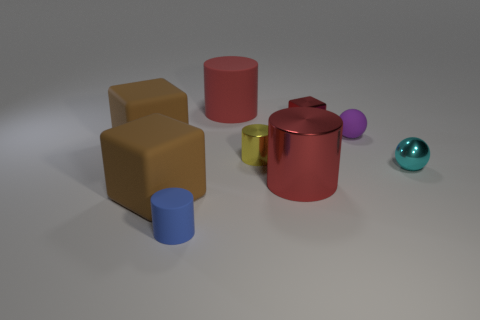There is a small object that is the same color as the big metal thing; what shape is it?
Make the answer very short. Cube. The other cylinder that is the same color as the big metallic cylinder is what size?
Your answer should be compact. Large. How many other objects are the same shape as the tiny red shiny object?
Provide a succinct answer. 2. What shape is the small metal thing that is on the right side of the metallic cube?
Your answer should be very brief. Sphere. There is a large rubber object that is behind the tiny red object; is there a large object to the left of it?
Give a very brief answer. Yes. What color is the big object that is to the left of the big red shiny cylinder and in front of the cyan shiny thing?
Keep it short and to the point. Brown. Is there a red shiny cylinder in front of the big cylinder in front of the rubber object right of the small yellow thing?
Give a very brief answer. No. What is the size of the other matte object that is the same shape as the big red rubber object?
Make the answer very short. Small. Is there anything else that has the same material as the yellow object?
Offer a terse response. Yes. Are there any balls?
Provide a succinct answer. Yes. 